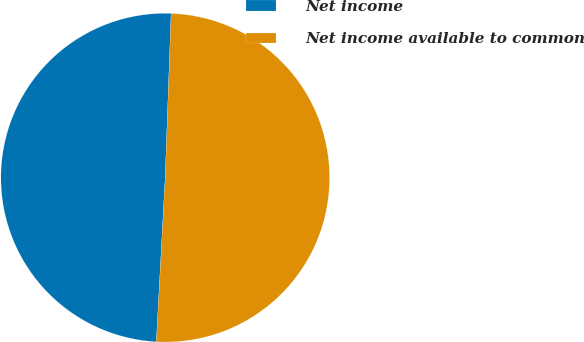Convert chart to OTSL. <chart><loc_0><loc_0><loc_500><loc_500><pie_chart><fcel>Net income<fcel>Net income available to common<nl><fcel>49.71%<fcel>50.29%<nl></chart> 